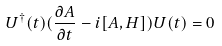Convert formula to latex. <formula><loc_0><loc_0><loc_500><loc_500>U ^ { \dagger } ( t ) ( \frac { \partial A } { \partial t } - i [ A , H ] ) U ( t ) = 0</formula> 